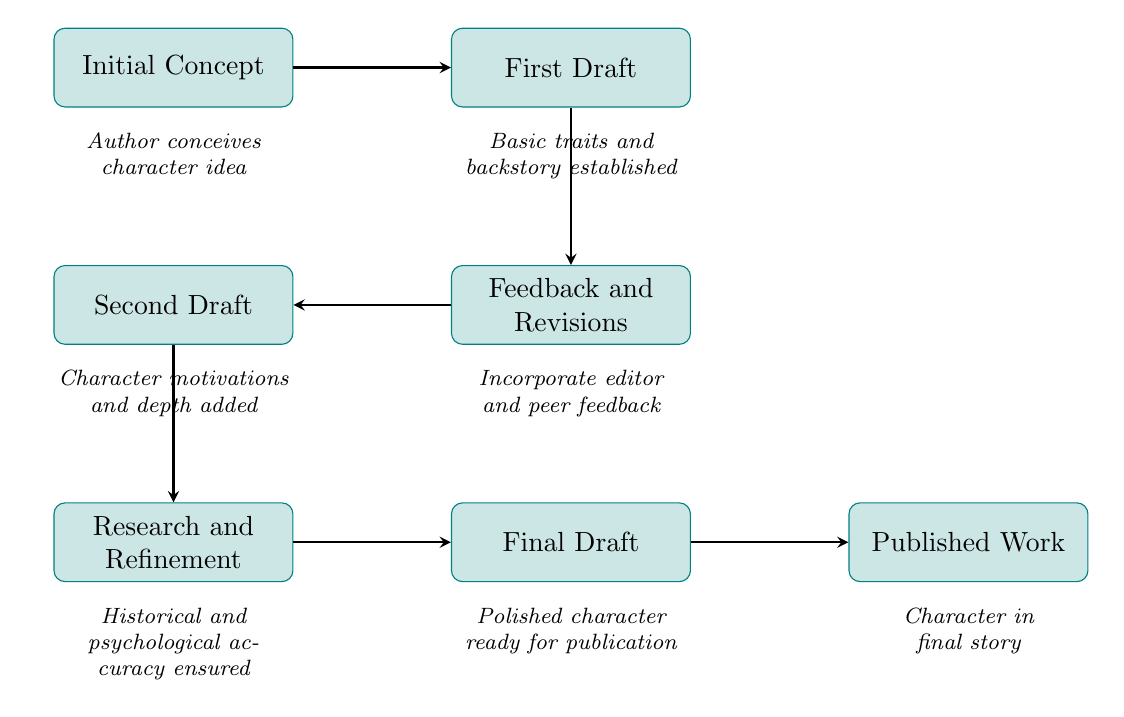What is the first node in the flow chart? The first node in the flow chart represents the starting point of the character development process, titled "Initial Concept." It indicates that the author conceives the character idea, which is the very first step.
Answer: Initial Concept How many nodes are in total in the diagram? By counting all the distinct numbered nodes presented in the flow chart, we find that there are seven nodes, indicating various stages in the character evolution process.
Answer: 7 What is the last step before publication? The last step before the final work is published is the "Final Draft," where the character is polished and ready for publication. Following this step is the actual published work.
Answer: Final Draft Which node follows "Feedback and Revisions"? According to the directional flow in the diagram, "Feedback and Revisions" directly leads to the node titled "Second Draft," indicating that it is the next step in the character development process.
Answer: Second Draft What is added in the second draft? In the second draft, the character's "motivations and depth" are added, enhancing the initial details established in the first draft and giving the character greater complexity.
Answer: Character motivations and depth added What process immediately follows the second draft? The process that immediately follows the second draft is labeled "Research and Refinement," which ensures that historical and psychological accuracy is maintained in the character's portrayal.
Answer: Research and Refinement How does the character evolve from the first draft to the final draft? The character evolves through multiple stages beginning with "Basic traits and backstory established" in the first draft, followed by receiving feedback, adding motivations and depth, ensuring accuracy, and finally polishing it in the final draft. This sequence illustrates a gradual and structured development.
Answer: Through feedback, depth, and refinement 